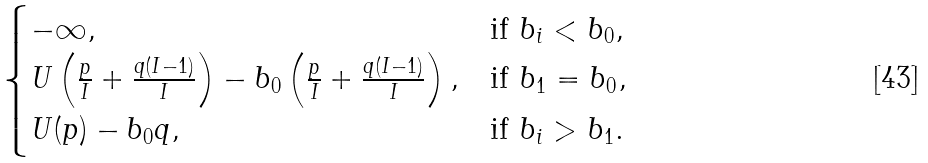<formula> <loc_0><loc_0><loc_500><loc_500>\begin{cases} - \infty , & \text {if } b _ { i } < b _ { 0 } , \\ U \left ( \frac { p } { I } + \frac { q ( I - 1 ) } { I } \right ) - b _ { 0 } \left ( \frac { p } { I } + \frac { q ( I - 1 ) } { I } \right ) , & \text {if } b _ { 1 } = b _ { 0 } , \\ U ( p ) - b _ { 0 } q , & \text {if } b _ { i } > b _ { 1 } . \end{cases}</formula> 